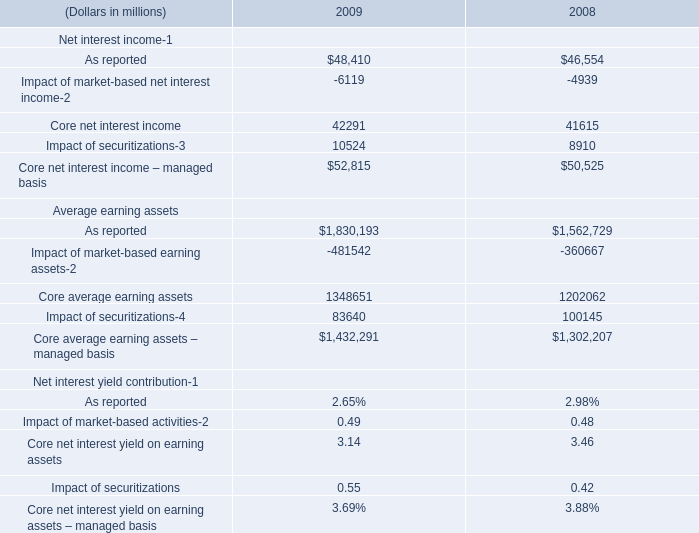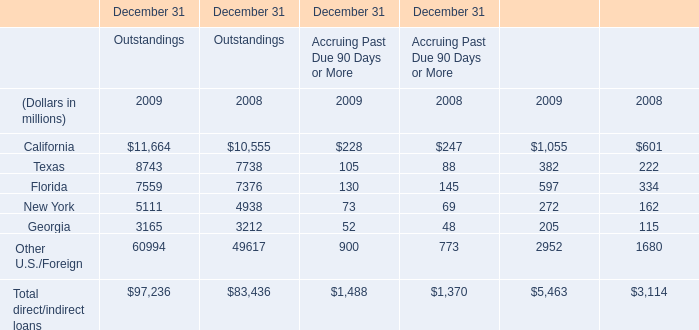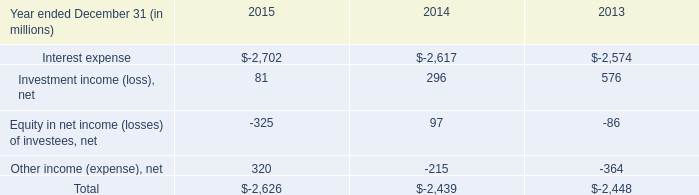what's the total amount of Texas of December 31 Outstandings 2008, and Impact of securitizations Average earning assets of 2009 ? 
Computations: (7738.0 + 83640.0)
Answer: 91378.0. 